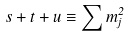<formula> <loc_0><loc_0><loc_500><loc_500>s + t + u \equiv \sum m _ { j } ^ { 2 }</formula> 